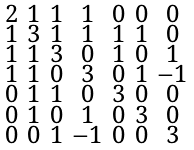<formula> <loc_0><loc_0><loc_500><loc_500>\begin{smallmatrix} 2 & 1 & 1 & 1 & 0 & 0 & 0 \\ 1 & 3 & 1 & 1 & 1 & 1 & 0 \\ 1 & 1 & 3 & 0 & 1 & 0 & 1 \\ 1 & 1 & 0 & 3 & 0 & 1 & - 1 \\ 0 & 1 & 1 & 0 & 3 & 0 & 0 \\ 0 & 1 & 0 & 1 & 0 & 3 & 0 \\ 0 & 0 & 1 & - 1 & 0 & 0 & 3 \end{smallmatrix}</formula> 